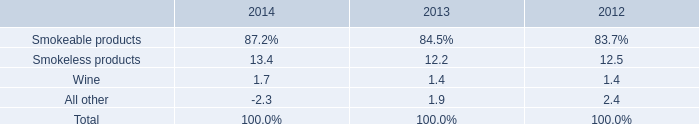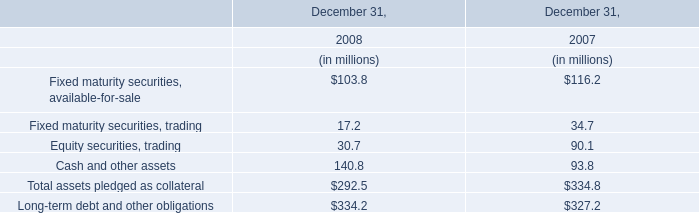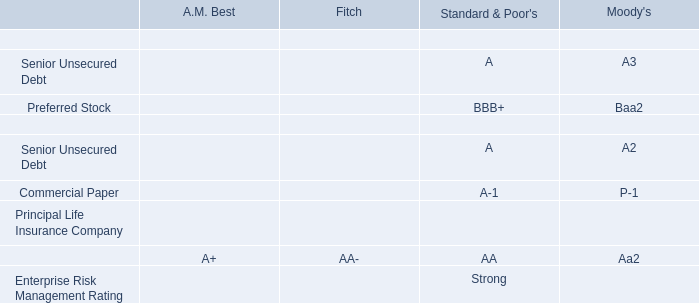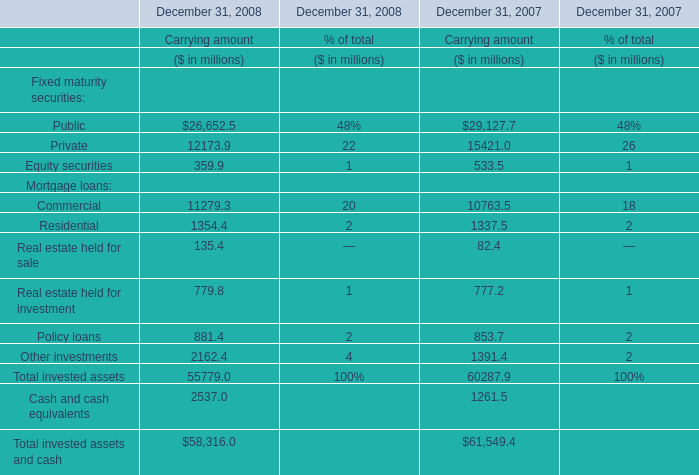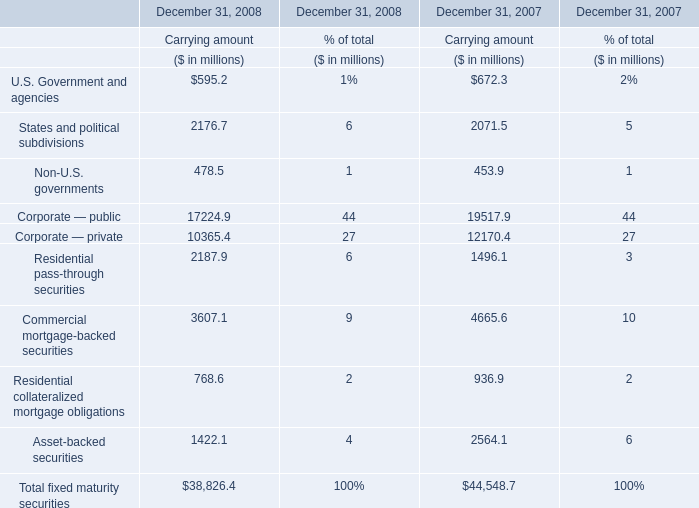What was the sum of elements for Carrying amount without those elements smaller than 10000 in 2008? (in million) 
Computations: (17224.9 + 10365.4)
Answer: 27590.3. 